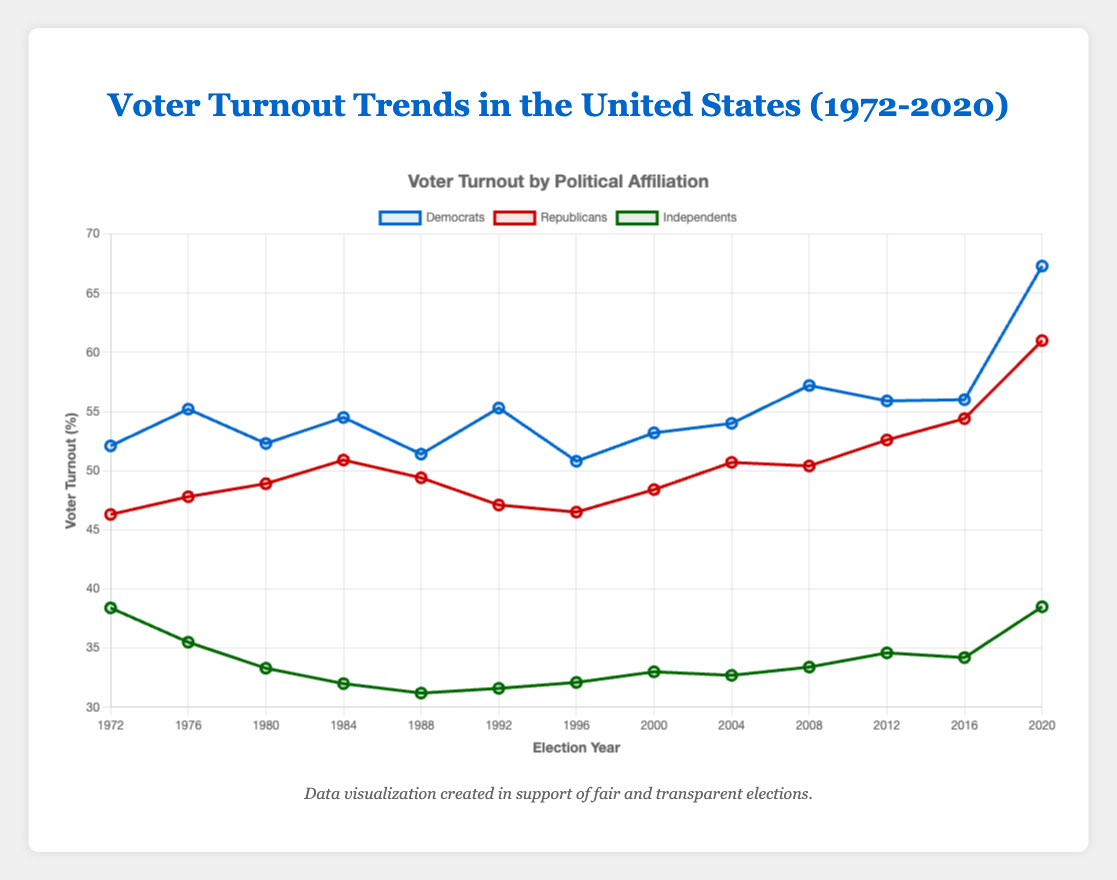What's the highest voter turnout percentage for Democrats, Republicans, and Independents across the years? To find the highest percentages, we check the maximum values for each group based on their data points. Democrats have a maximum of 67.3 in 2020, Republicans have a maximum of 61.0 in 2020, and Independents have a maximum of 38.5 in 2020.
Answer: Democrats: 67.3, Republicans: 61.0, Independents: 38.5 In which year did Democrats have their lowest voter turnout percentage? By analyzing the data points for Democrats, we see that the lowest value is 50.8, which occurs in 1996.
Answer: 1996 Compare voter turnout between Democrats and Republicans in 2020. Who had a higher turnout and by how much? In 2020, Democrats had a turnout of 67.3 and Republicans had 61.0. To find the difference, we subtract Republican turnout from Democrat turnout: 67.3 - 61.0 = 6.3.
Answer: Democrats by 6.3 Which group had the most consistent voter turnout trend over the years? To determine consistency, we look at the variation in the turnout percentages over the years. Independents show the least variation and have the smallest range between their highest (38.5) and lowest (31.2) turnouts, making them the most consistent.
Answer: Independents What is the average voter turnout for Democrats from 1972 to 2020? Sum the Democratic voter turnout percentages (52.1 + 55.2 + 52.3 + 54.5 + 51.4 + 55.3 + 50.8 + 53.2 + 54.0 + 57.2 + 55.9 + 56.0 + 67.3) = 714.2. Divide by the number of years (13): 714.2 / 13 ≈ 54.94.
Answer: 54.94 How did the voter turnout for Republicans change between 1984 and 1988? For Republicans, the voter turnout in 1984 was 50.9 and in 1988 was 49.4. The change is found by subtracting the turnout in 1988 from 1984: 49.4 - 50.9 = -1.5, indicating a decrease.
Answer: Decreased by 1.5 Determine the year with the most significant turnout difference between Democrats and Republicans. What was the difference? We calculate the differences for each year:
1972: 52.1 - 46.3 = 5.8
1976: 55.2 - 47.8 = 7.4
1980: 52.3 - 48.9 = 3.4
1984: 54.5 - 50.9 = 3.6
1988: 51.4 - 49.4 = 2.0
1992: 55.3 - 47.1 = 8.2
1996: 50.8 - 46.5 = 4.3
2000: 53.2 - 48.4 = 4.8
2004: 54.0 - 50.7 = 3.3
2008: 57.2 - 50.4 = 6.8
2012: 55.9 - 52.6 = 3.3
2016: 56.0 - 54.4 = 1.6
2020: 67.3 - 61.0 = 6.3
The greatest difference is in 1992, with a difference of 8.2.
Answer: 1992, with a difference of 8.2 